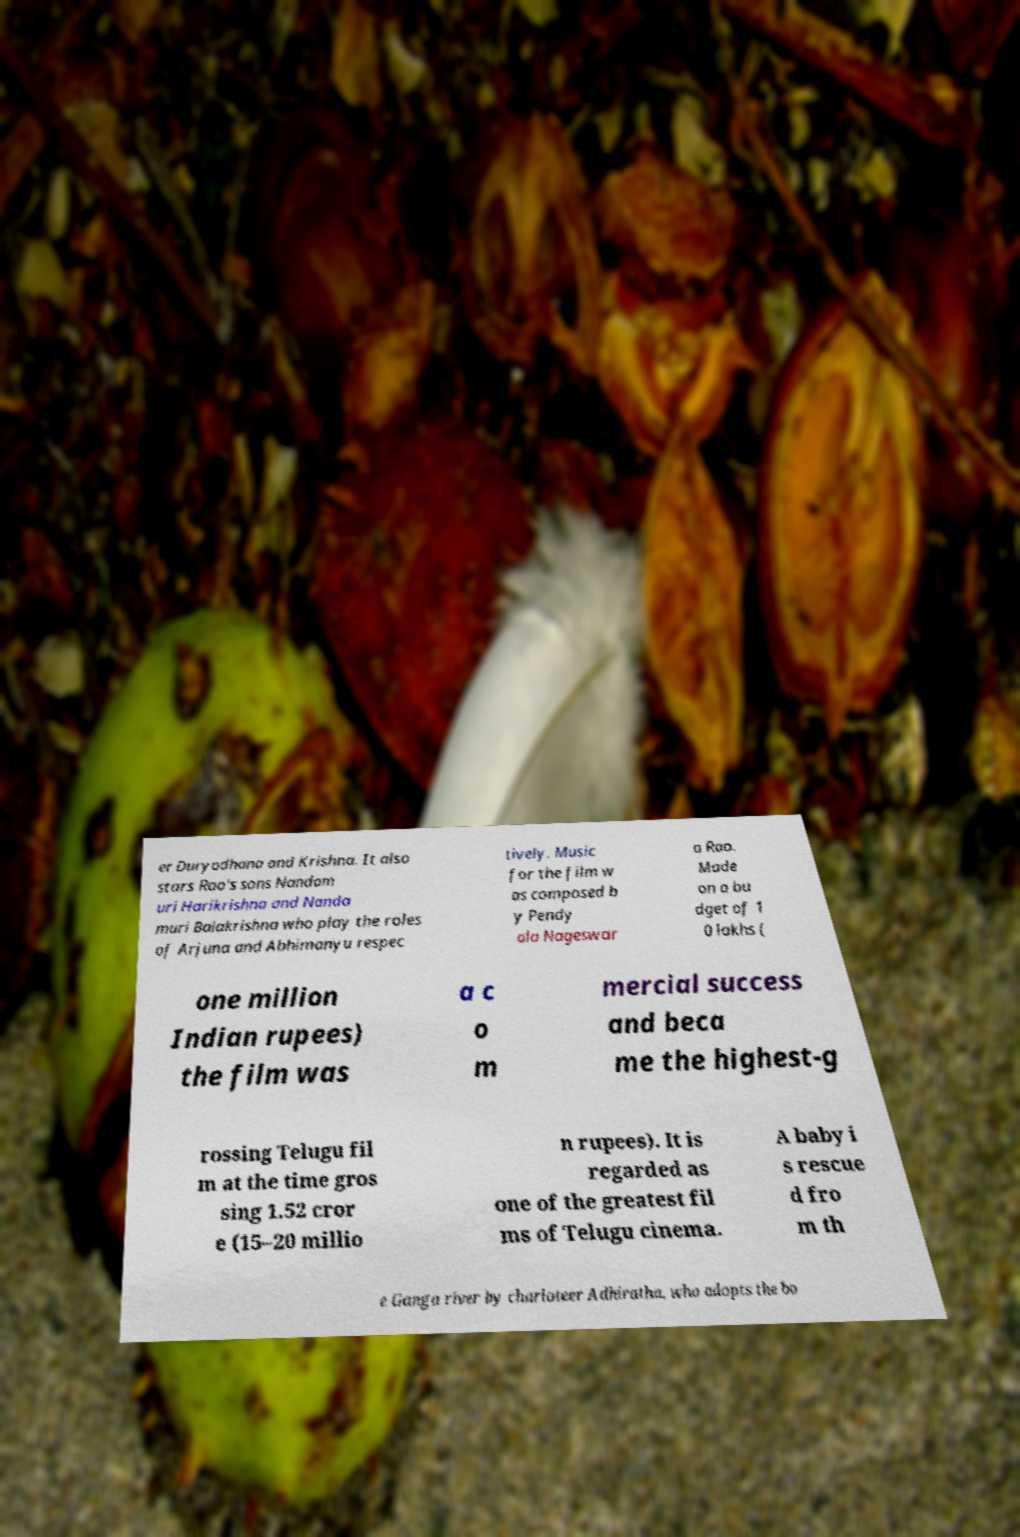Can you read and provide the text displayed in the image?This photo seems to have some interesting text. Can you extract and type it out for me? er Duryodhana and Krishna. It also stars Rao's sons Nandam uri Harikrishna and Nanda muri Balakrishna who play the roles of Arjuna and Abhimanyu respec tively. Music for the film w as composed b y Pendy ala Nageswar a Rao. Made on a bu dget of 1 0 lakhs ( one million Indian rupees) the film was a c o m mercial success and beca me the highest-g rossing Telugu fil m at the time gros sing 1.52 cror e (15–20 millio n rupees). It is regarded as one of the greatest fil ms of Telugu cinema. A baby i s rescue d fro m th e Ganga river by charioteer Adhiratha, who adopts the bo 